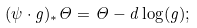<formula> <loc_0><loc_0><loc_500><loc_500>( \psi \cdot g ) _ { * } \Theta = \Theta - d \log ( g ) ;</formula> 